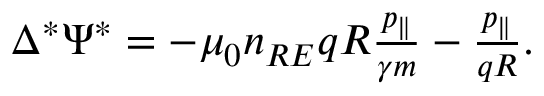Convert formula to latex. <formula><loc_0><loc_0><loc_500><loc_500>\begin{array} { r } { \Delta ^ { * } \Psi ^ { * } = - \mu _ { 0 } n _ { R E } q R \frac { p _ { \| } } { \gamma m } - \frac { p _ { \| } } { q R } . } \end{array}</formula> 